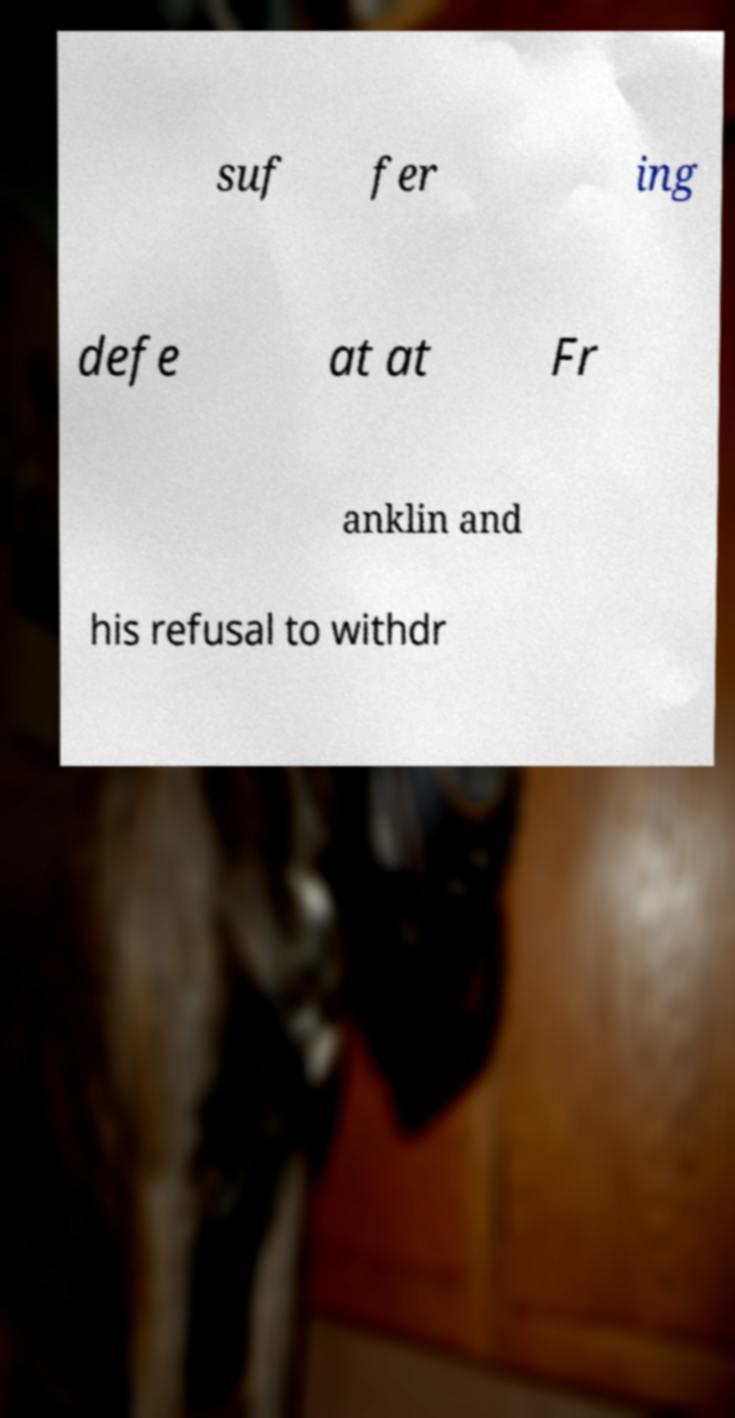Please read and relay the text visible in this image. What does it say? suf fer ing defe at at Fr anklin and his refusal to withdr 